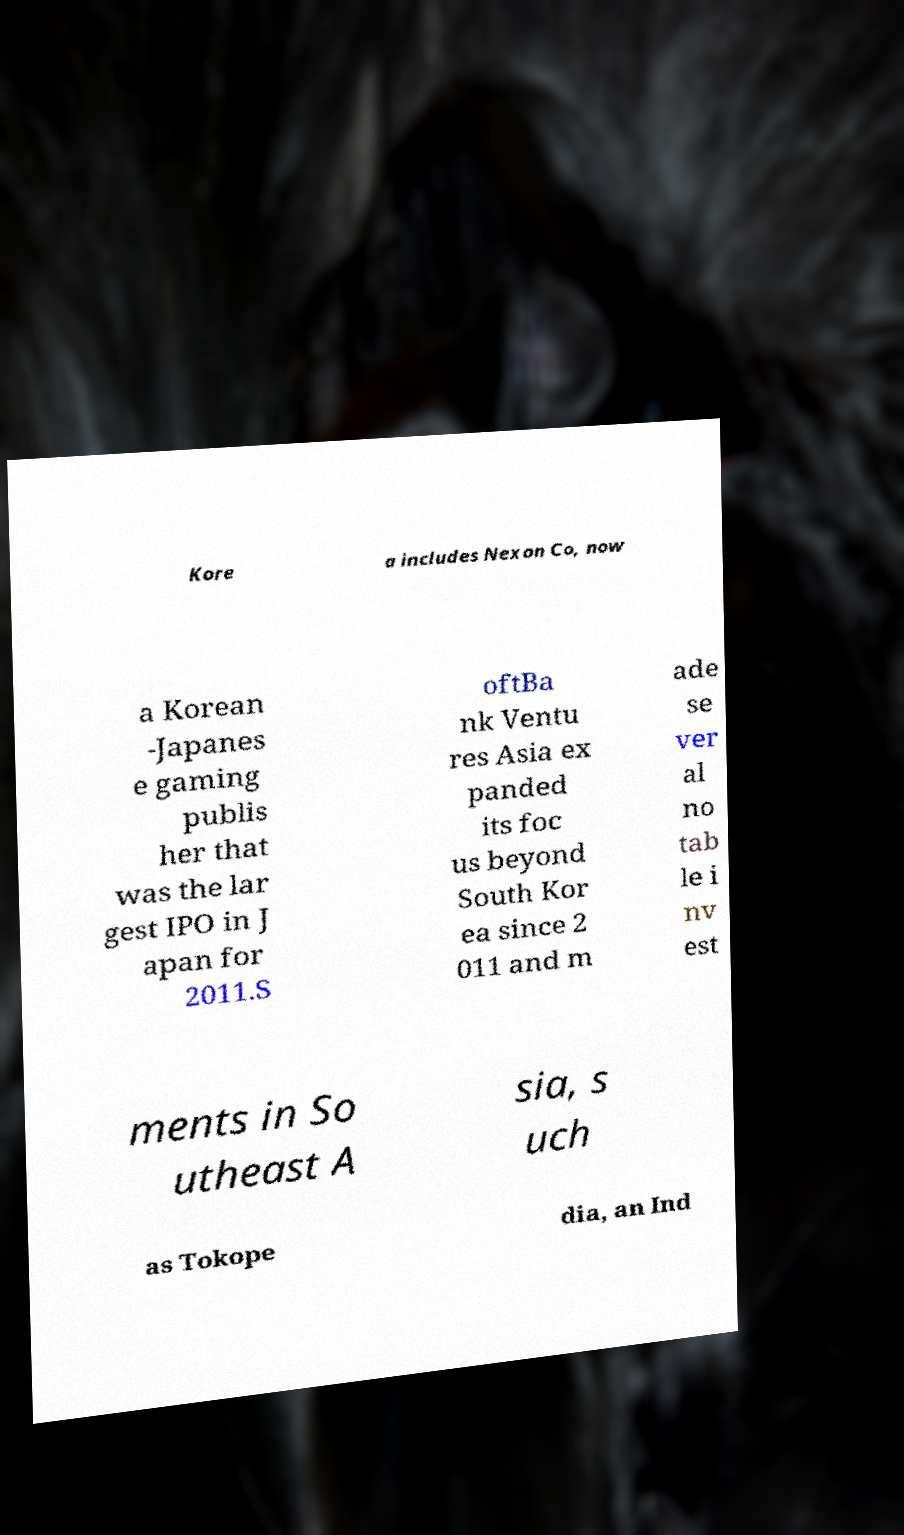There's text embedded in this image that I need extracted. Can you transcribe it verbatim? Kore a includes Nexon Co, now a Korean -Japanes e gaming publis her that was the lar gest IPO in J apan for 2011.S oftBa nk Ventu res Asia ex panded its foc us beyond South Kor ea since 2 011 and m ade se ver al no tab le i nv est ments in So utheast A sia, s uch as Tokope dia, an Ind 